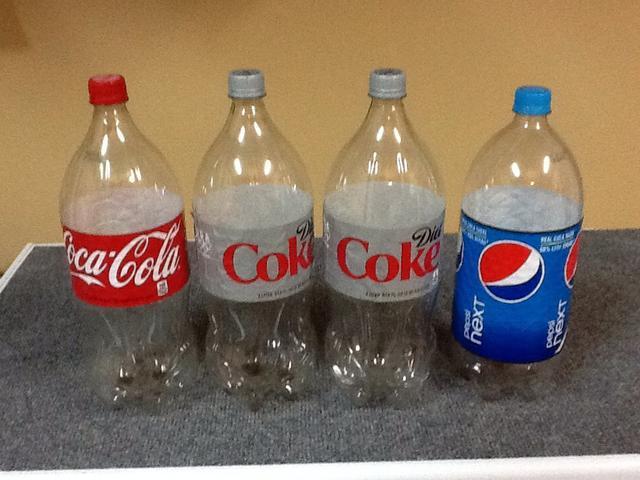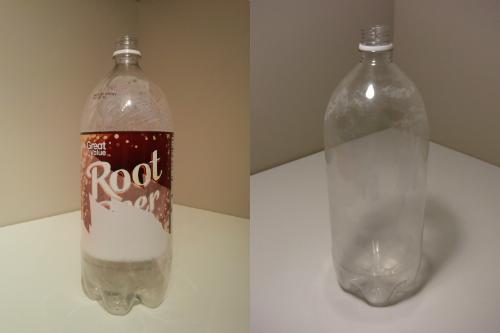The first image is the image on the left, the second image is the image on the right. Given the left and right images, does the statement "At least two bottles have caps on them." hold true? Answer yes or no. Yes. The first image is the image on the left, the second image is the image on the right. Considering the images on both sides, is "One of the pictures shows at least two bottles standing upright side by side." valid? Answer yes or no. Yes. 